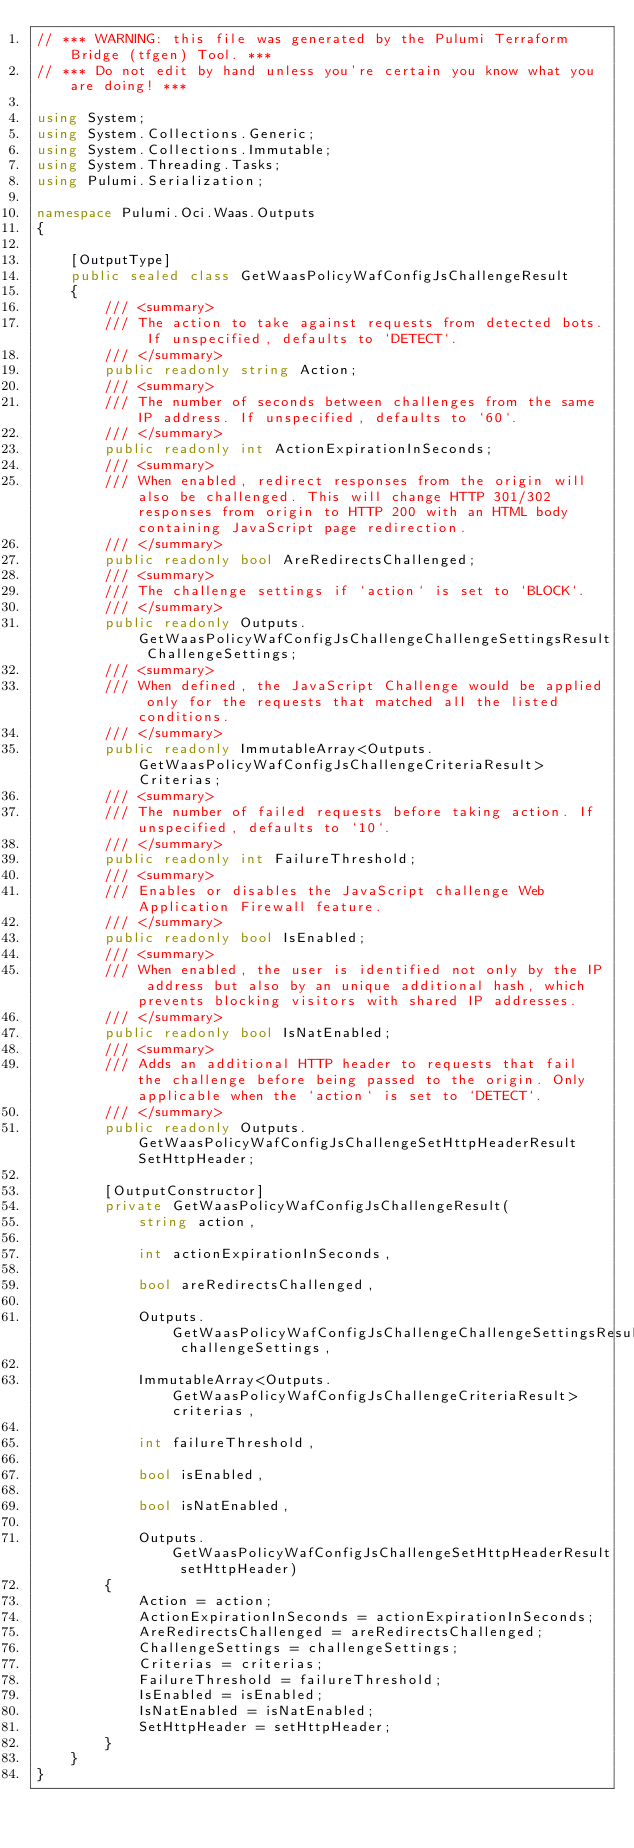<code> <loc_0><loc_0><loc_500><loc_500><_C#_>// *** WARNING: this file was generated by the Pulumi Terraform Bridge (tfgen) Tool. ***
// *** Do not edit by hand unless you're certain you know what you are doing! ***

using System;
using System.Collections.Generic;
using System.Collections.Immutable;
using System.Threading.Tasks;
using Pulumi.Serialization;

namespace Pulumi.Oci.Waas.Outputs
{

    [OutputType]
    public sealed class GetWaasPolicyWafConfigJsChallengeResult
    {
        /// <summary>
        /// The action to take against requests from detected bots. If unspecified, defaults to `DETECT`.
        /// </summary>
        public readonly string Action;
        /// <summary>
        /// The number of seconds between challenges from the same IP address. If unspecified, defaults to `60`.
        /// </summary>
        public readonly int ActionExpirationInSeconds;
        /// <summary>
        /// When enabled, redirect responses from the origin will also be challenged. This will change HTTP 301/302 responses from origin to HTTP 200 with an HTML body containing JavaScript page redirection.
        /// </summary>
        public readonly bool AreRedirectsChallenged;
        /// <summary>
        /// The challenge settings if `action` is set to `BLOCK`.
        /// </summary>
        public readonly Outputs.GetWaasPolicyWafConfigJsChallengeChallengeSettingsResult ChallengeSettings;
        /// <summary>
        /// When defined, the JavaScript Challenge would be applied only for the requests that matched all the listed conditions.
        /// </summary>
        public readonly ImmutableArray<Outputs.GetWaasPolicyWafConfigJsChallengeCriteriaResult> Criterias;
        /// <summary>
        /// The number of failed requests before taking action. If unspecified, defaults to `10`.
        /// </summary>
        public readonly int FailureThreshold;
        /// <summary>
        /// Enables or disables the JavaScript challenge Web Application Firewall feature.
        /// </summary>
        public readonly bool IsEnabled;
        /// <summary>
        /// When enabled, the user is identified not only by the IP address but also by an unique additional hash, which prevents blocking visitors with shared IP addresses.
        /// </summary>
        public readonly bool IsNatEnabled;
        /// <summary>
        /// Adds an additional HTTP header to requests that fail the challenge before being passed to the origin. Only applicable when the `action` is set to `DETECT`.
        /// </summary>
        public readonly Outputs.GetWaasPolicyWafConfigJsChallengeSetHttpHeaderResult SetHttpHeader;

        [OutputConstructor]
        private GetWaasPolicyWafConfigJsChallengeResult(
            string action,

            int actionExpirationInSeconds,

            bool areRedirectsChallenged,

            Outputs.GetWaasPolicyWafConfigJsChallengeChallengeSettingsResult challengeSettings,

            ImmutableArray<Outputs.GetWaasPolicyWafConfigJsChallengeCriteriaResult> criterias,

            int failureThreshold,

            bool isEnabled,

            bool isNatEnabled,

            Outputs.GetWaasPolicyWafConfigJsChallengeSetHttpHeaderResult setHttpHeader)
        {
            Action = action;
            ActionExpirationInSeconds = actionExpirationInSeconds;
            AreRedirectsChallenged = areRedirectsChallenged;
            ChallengeSettings = challengeSettings;
            Criterias = criterias;
            FailureThreshold = failureThreshold;
            IsEnabled = isEnabled;
            IsNatEnabled = isNatEnabled;
            SetHttpHeader = setHttpHeader;
        }
    }
}
</code> 